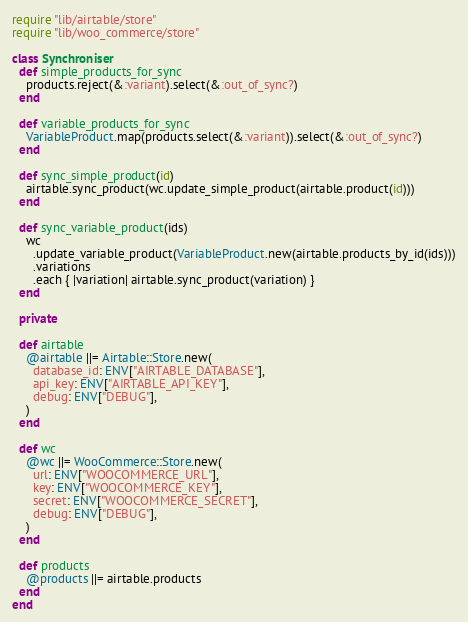<code> <loc_0><loc_0><loc_500><loc_500><_Ruby_>require "lib/airtable/store"
require "lib/woo_commerce/store"

class Synchroniser
  def simple_products_for_sync
    products.reject(&:variant).select(&:out_of_sync?)
  end

  def variable_products_for_sync
    VariableProduct.map(products.select(&:variant)).select(&:out_of_sync?)
  end

  def sync_simple_product(id)
    airtable.sync_product(wc.update_simple_product(airtable.product(id)))
  end

  def sync_variable_product(ids)
    wc
      .update_variable_product(VariableProduct.new(airtable.products_by_id(ids)))
      .variations
      .each { |variation| airtable.sync_product(variation) }
  end

  private

  def airtable
    @airtable ||= Airtable::Store.new(
      database_id: ENV["AIRTABLE_DATABASE"],
      api_key: ENV["AIRTABLE_API_KEY"],
      debug: ENV["DEBUG"],
    )
  end

  def wc
    @wc ||= WooCommerce::Store.new(
      url: ENV["WOOCOMMERCE_URL"],
      key: ENV["WOOCOMMERCE_KEY"],
      secret: ENV["WOOCOMMERCE_SECRET"],
      debug: ENV["DEBUG"],
    )
  end

  def products
    @products ||= airtable.products
  end
end
</code> 